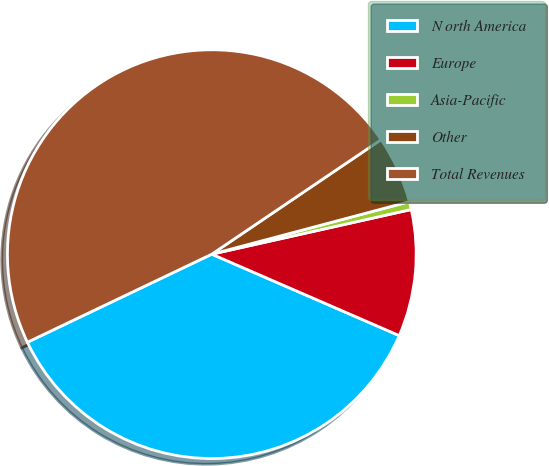Convert chart to OTSL. <chart><loc_0><loc_0><loc_500><loc_500><pie_chart><fcel>N orth America<fcel>Europe<fcel>Asia-Pacific<fcel>Other<fcel>Total Revenues<nl><fcel>36.39%<fcel>10.03%<fcel>0.63%<fcel>5.33%<fcel>47.63%<nl></chart> 